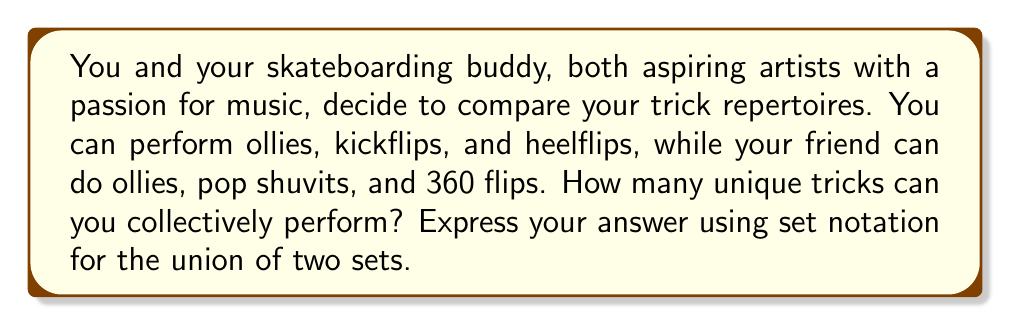Solve this math problem. Let's approach this step-by-step using set theory:

1. Define the sets:
   Let $A$ be your set of tricks: $A = \{\text{ollie}, \text{kickflip}, \text{heelflip}\}$
   Let $B$ be your friend's set of tricks: $B = \{\text{ollie}, \text{pop shuvit}, \text{360 flip}\}$

2. We need to find the union of these sets, denoted as $A \cup B$. The union includes all unique elements from both sets.

3. List all elements in both sets:
   $A \cup B = \{\text{ollie}, \text{kickflip}, \text{heelflip}, \text{pop shuvit}, \text{360 flip}\}$

4. Count the unique elements:
   Note that "ollie" appears in both sets, but we only count it once in the union.

5. The number of elements in the union is 5.

Therefore, you can collectively perform 5 unique tricks.

In set notation, we write this as:
$$|A \cup B| = 5$$

Where $|A \cup B|$ denotes the cardinality (number of elements) of the union of sets $A$ and $B$.
Answer: $|A \cup B| = 5$ 